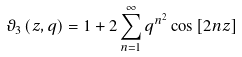Convert formula to latex. <formula><loc_0><loc_0><loc_500><loc_500>\vartheta _ { 3 } \left ( z , q \right ) = 1 + 2 \sum _ { n = 1 } ^ { \infty } q ^ { n ^ { 2 } } \cos \left [ 2 n z \right ]</formula> 